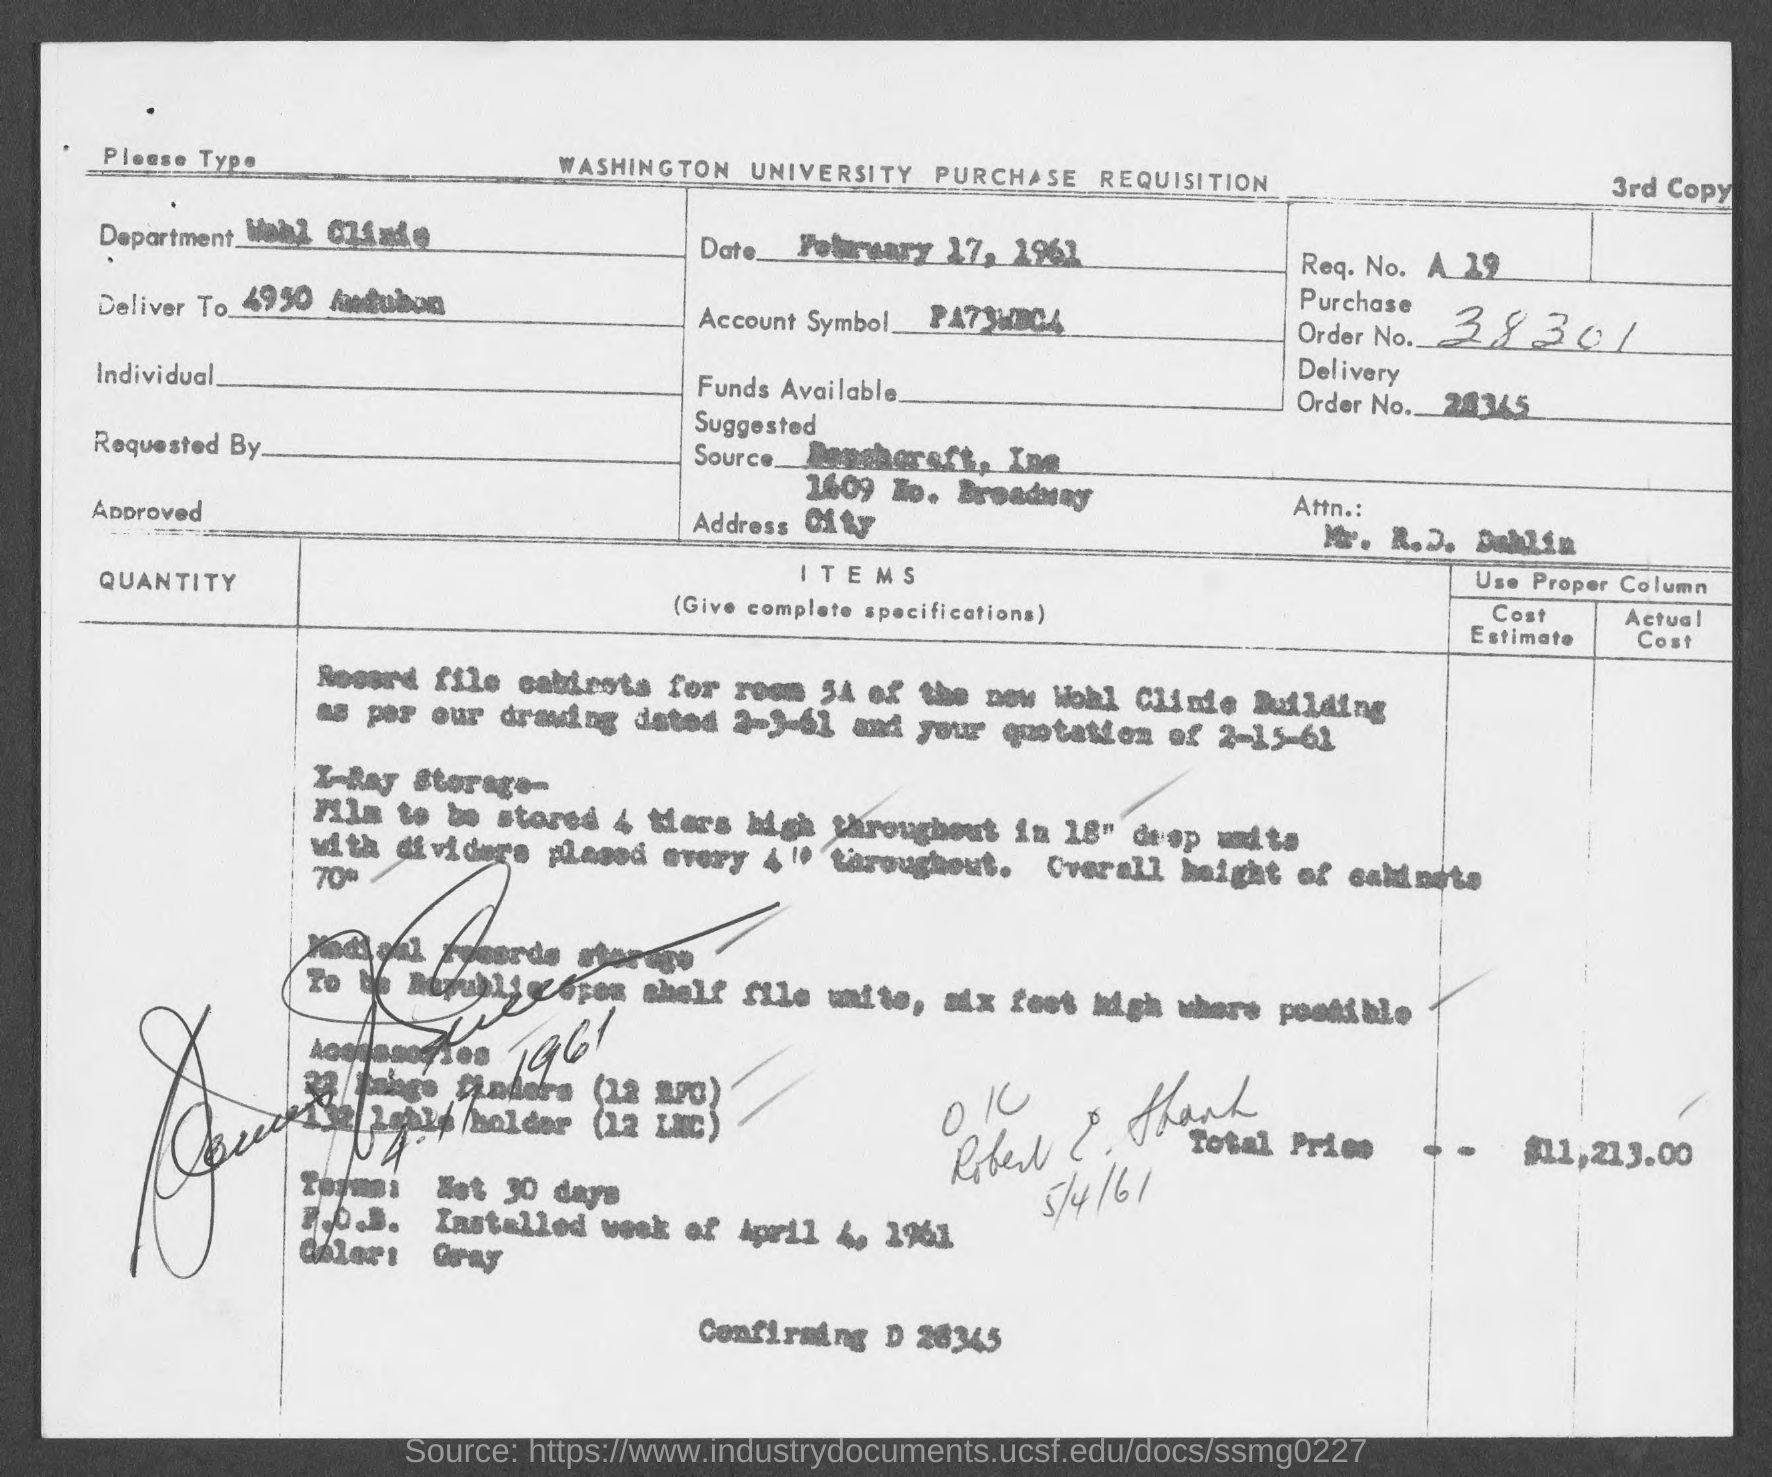Highlight a few significant elements in this photo. The date mentioned in the given page is February 17, 1961. The total price mentioned in the given form is $11,213.00. What is the name of the department mentioned in the given form? It is the Wohl Clinic. The given page contains a purchase order number of 38301. 